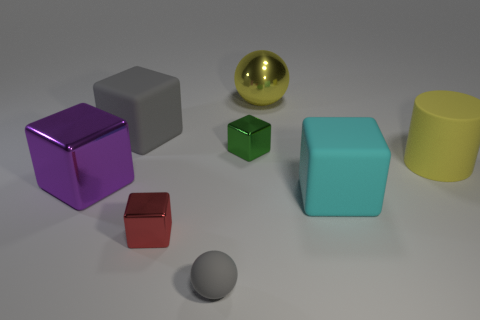How many rubber objects are either tiny gray balls or red blocks?
Offer a terse response. 1. There is a large block that is in front of the big gray rubber object and on the right side of the purple block; what is its color?
Provide a short and direct response. Cyan. Do the red object in front of the yellow matte object and the gray matte sphere have the same size?
Provide a short and direct response. Yes. How many things are either metal cubes that are right of the gray ball or tiny green blocks?
Offer a very short reply. 1. Are there any yellow rubber cylinders of the same size as the gray matte sphere?
Keep it short and to the point. No. There is a gray ball that is the same size as the green metal block; what is its material?
Your response must be concise. Rubber. There is a thing that is behind the tiny green block and in front of the large yellow ball; what is its shape?
Your answer should be compact. Cube. What color is the sphere that is behind the big metallic cube?
Offer a very short reply. Yellow. How big is the metallic thing that is both in front of the big sphere and to the right of the red metallic object?
Provide a succinct answer. Small. Is the tiny ball made of the same material as the small block that is behind the yellow cylinder?
Your answer should be compact. No. 